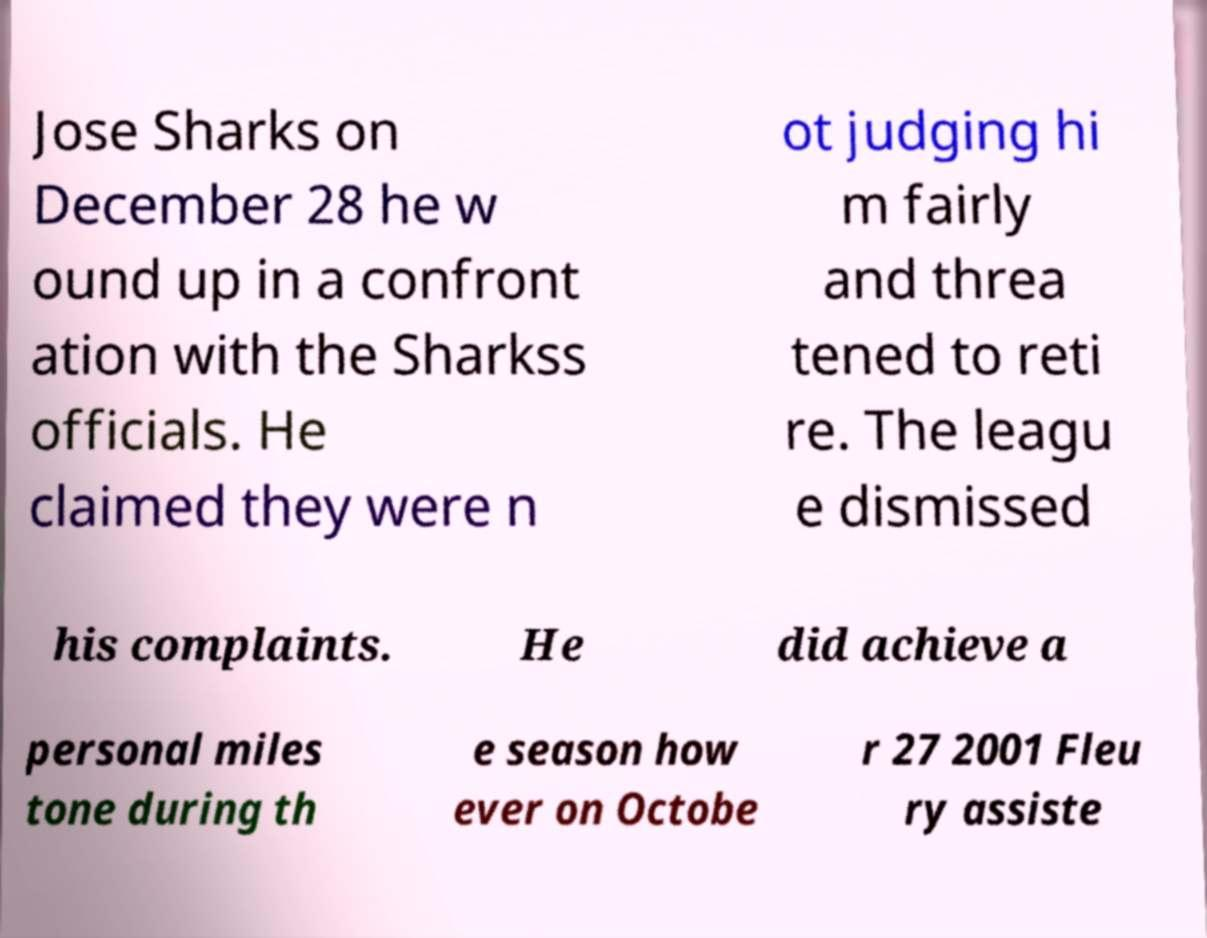What messages or text are displayed in this image? I need them in a readable, typed format. Jose Sharks on December 28 he w ound up in a confront ation with the Sharkss officials. He claimed they were n ot judging hi m fairly and threa tened to reti re. The leagu e dismissed his complaints. He did achieve a personal miles tone during th e season how ever on Octobe r 27 2001 Fleu ry assiste 